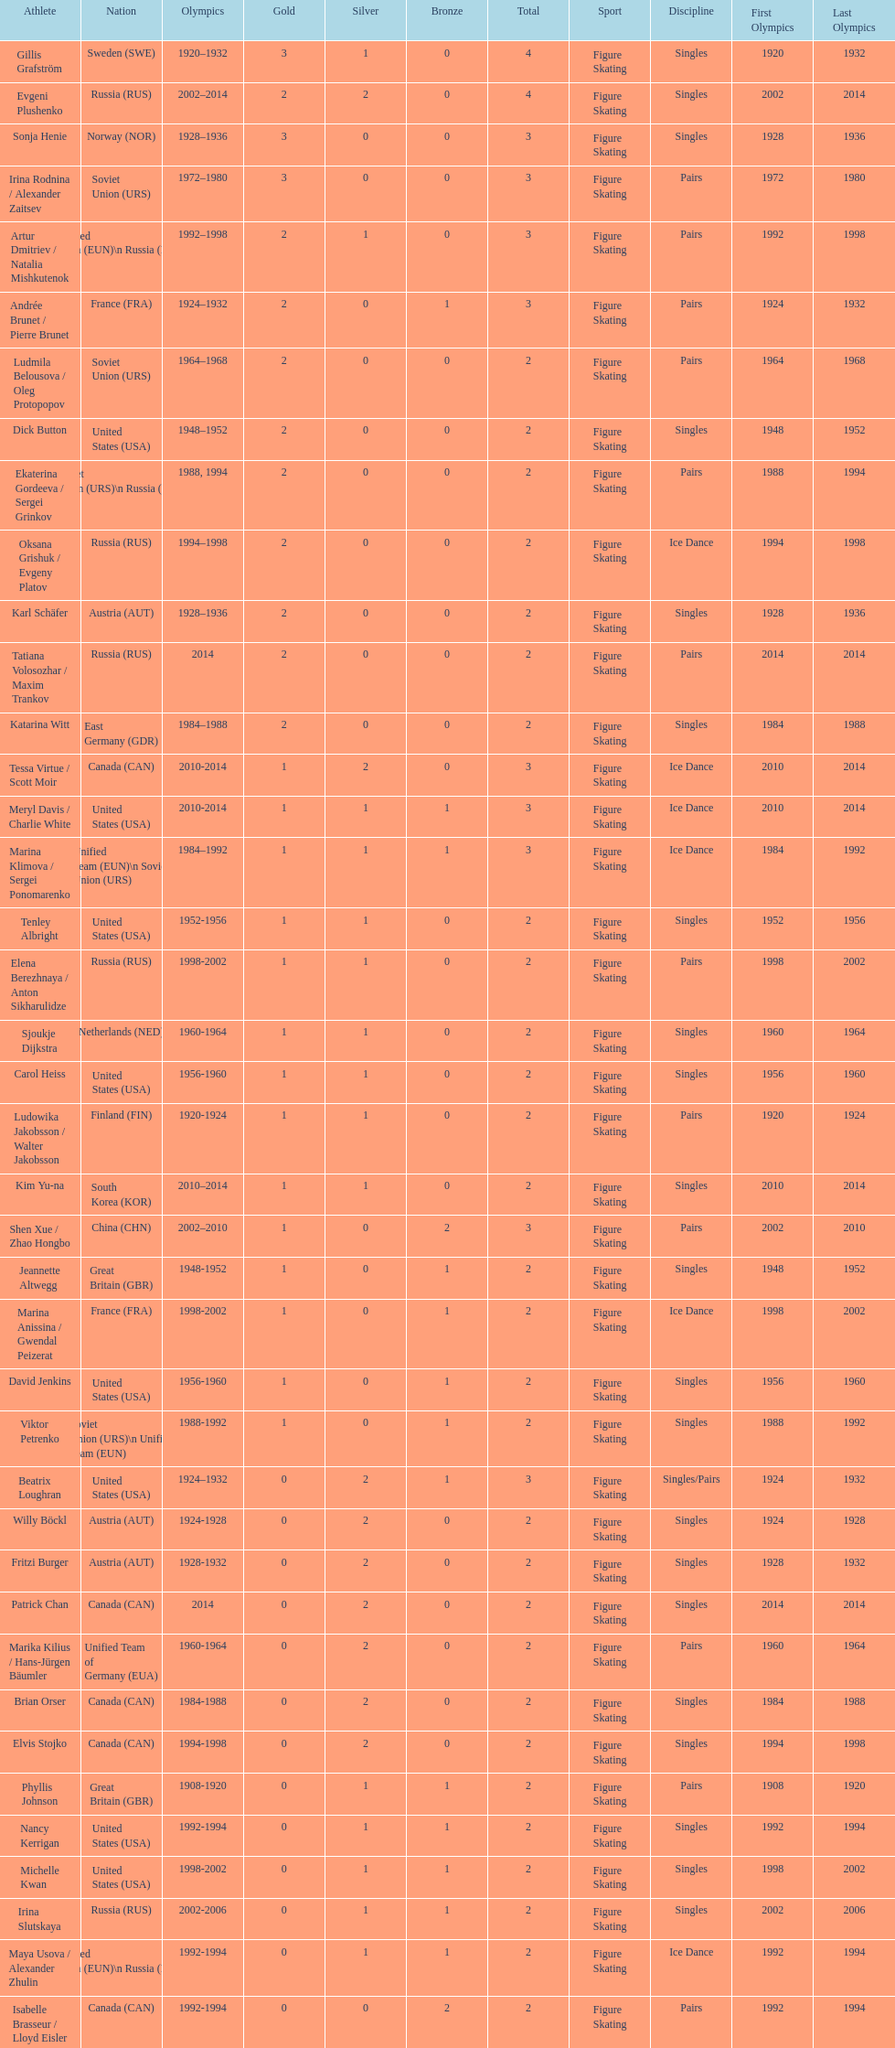How many silver medals did evgeni plushenko get? 2. 